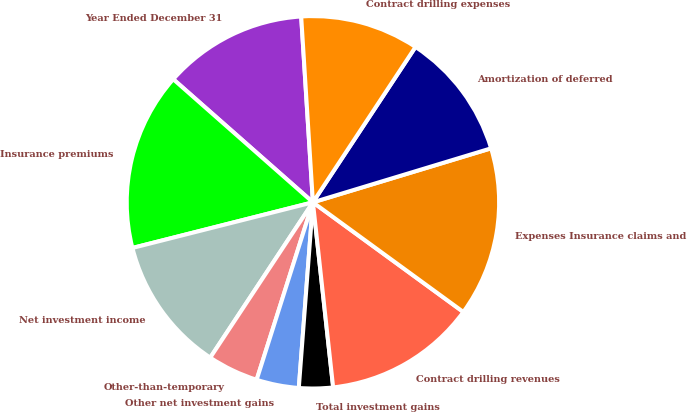<chart> <loc_0><loc_0><loc_500><loc_500><pie_chart><fcel>Year Ended December 31<fcel>Insurance premiums<fcel>Net investment income<fcel>Other-than-temporary<fcel>Other net investment gains<fcel>Total investment gains<fcel>Contract drilling revenues<fcel>Expenses Insurance claims and<fcel>Amortization of deferred<fcel>Contract drilling expenses<nl><fcel>12.5%<fcel>15.44%<fcel>11.76%<fcel>4.41%<fcel>3.68%<fcel>2.94%<fcel>13.24%<fcel>14.71%<fcel>11.03%<fcel>10.29%<nl></chart> 